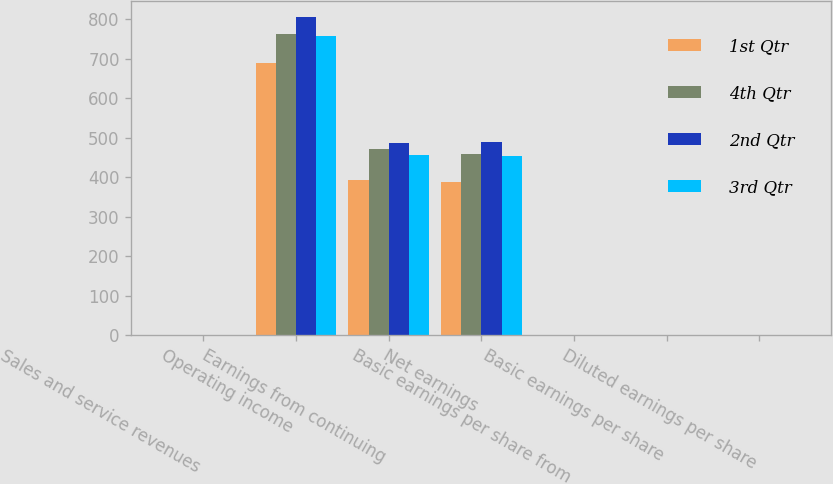Convert chart to OTSL. <chart><loc_0><loc_0><loc_500><loc_500><stacked_bar_chart><ecel><fcel>Sales and service revenues<fcel>Operating income<fcel>Earnings from continuing<fcel>Net earnings<fcel>Basic earnings per share from<fcel>Basic earnings per share<fcel>Diluted earnings per share<nl><fcel>1st Qtr<fcel>1.415<fcel>690<fcel>394<fcel>387<fcel>1.14<fcel>1.12<fcel>1.1<nl><fcel>4th Qtr<fcel>1.415<fcel>763<fcel>472<fcel>460<fcel>1.37<fcel>1.34<fcel>1.31<nl><fcel>2nd Qtr<fcel>1.415<fcel>806<fcel>488<fcel>489<fcel>1.43<fcel>1.44<fcel>1.4<nl><fcel>3rd Qtr<fcel>1.415<fcel>759<fcel>457<fcel>454<fcel>1.35<fcel>1.34<fcel>1.31<nl></chart> 